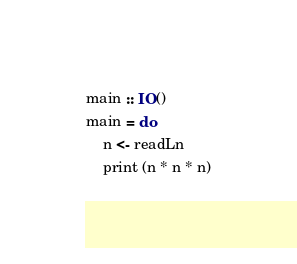Convert code to text. <code><loc_0><loc_0><loc_500><loc_500><_Haskell_>main :: IO()
main = do
    n <- readLn
    print (n * n * n)</code> 